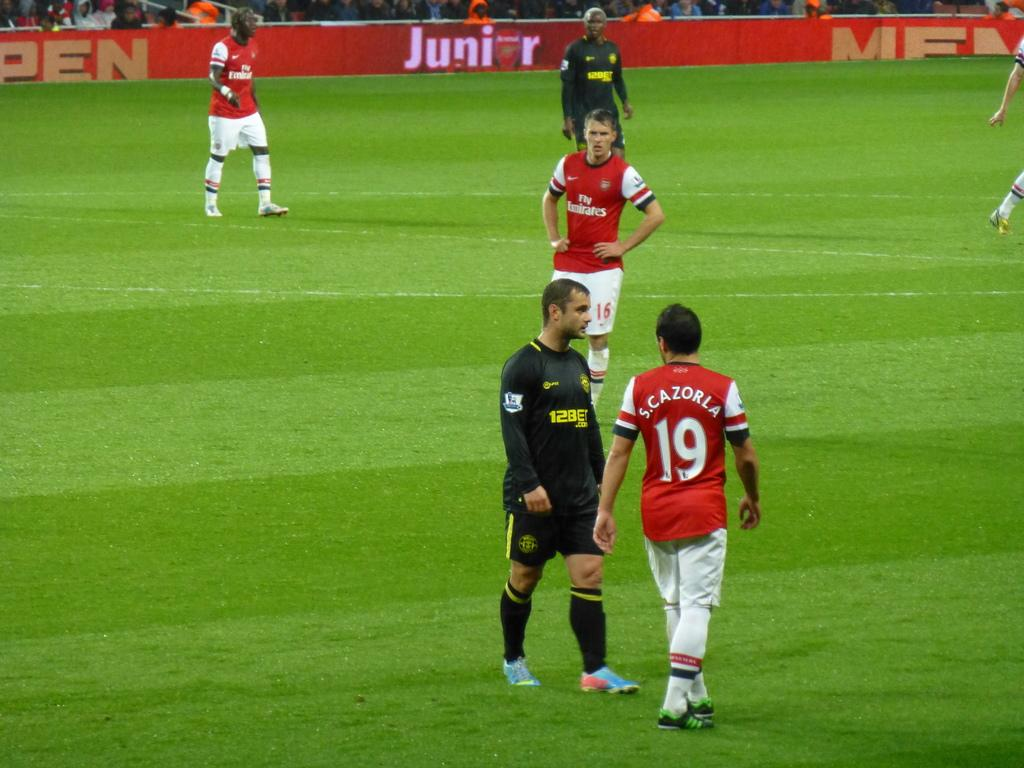What is happening in the image? There are players on a ground in the image. What can be seen in the background of the image? There is a banner in the background of the image. What is written on the banner? There is text on the banner. Where is the tub located in the image? There is no tub present in the image. What type of vest is being worn by the players in the image? The players in the image are not wearing vests; they are likely wearing sports attire. 